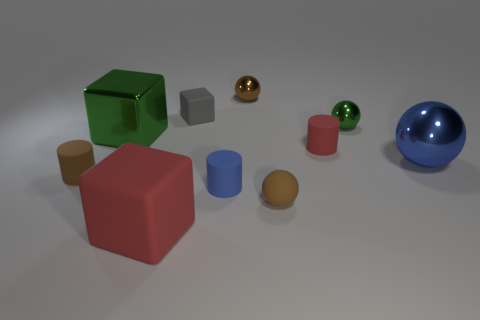Subtract all cylinders. How many objects are left? 7 Subtract 1 brown cylinders. How many objects are left? 9 Subtract all tiny gray things. Subtract all small blue things. How many objects are left? 8 Add 3 red matte cylinders. How many red matte cylinders are left? 4 Add 5 large green objects. How many large green objects exist? 6 